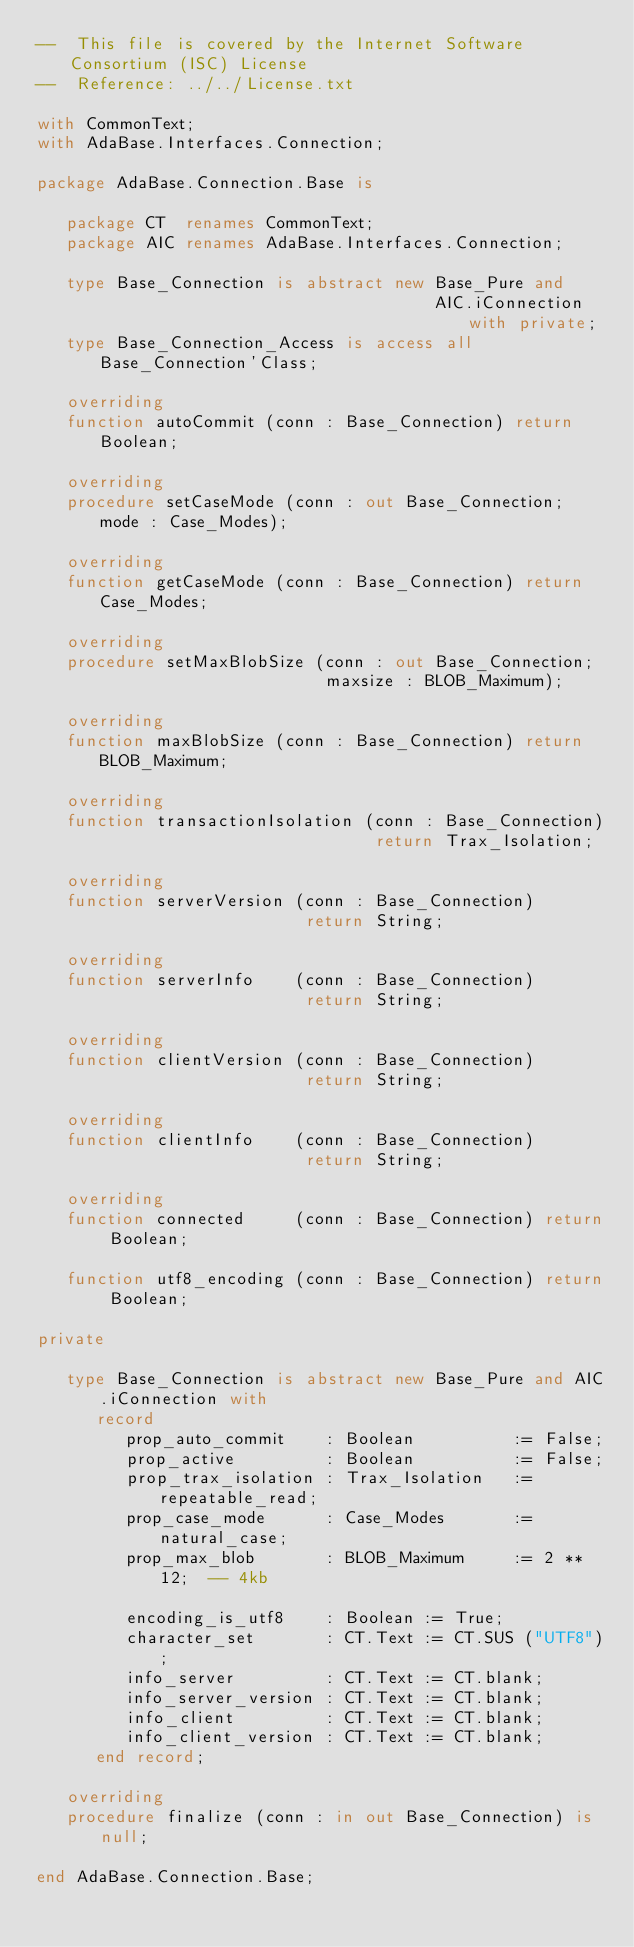<code> <loc_0><loc_0><loc_500><loc_500><_Ada_>--  This file is covered by the Internet Software Consortium (ISC) License
--  Reference: ../../License.txt

with CommonText;
with AdaBase.Interfaces.Connection;

package AdaBase.Connection.Base is

   package CT  renames CommonText;
   package AIC renames AdaBase.Interfaces.Connection;

   type Base_Connection is abstract new Base_Pure and
                                        AIC.iConnection with private;
   type Base_Connection_Access is access all Base_Connection'Class;

   overriding
   function autoCommit (conn : Base_Connection) return Boolean;

   overriding
   procedure setCaseMode (conn : out Base_Connection; mode : Case_Modes);

   overriding
   function getCaseMode (conn : Base_Connection) return Case_Modes;

   overriding
   procedure setMaxBlobSize (conn : out Base_Connection;
                             maxsize : BLOB_Maximum);

   overriding
   function maxBlobSize (conn : Base_Connection) return BLOB_Maximum;

   overriding
   function transactionIsolation (conn : Base_Connection)
                                  return Trax_Isolation;

   overriding
   function serverVersion (conn : Base_Connection)
                           return String;

   overriding
   function serverInfo    (conn : Base_Connection)
                           return String;

   overriding
   function clientVersion (conn : Base_Connection)
                           return String;

   overriding
   function clientInfo    (conn : Base_Connection)
                           return String;

   overriding
   function connected     (conn : Base_Connection) return Boolean;

   function utf8_encoding (conn : Base_Connection) return Boolean;

private

   type Base_Connection is abstract new Base_Pure and AIC.iConnection with
      record
         prop_auto_commit    : Boolean          := False;
         prop_active         : Boolean          := False;
         prop_trax_isolation : Trax_Isolation   := repeatable_read;
         prop_case_mode      : Case_Modes       := natural_case;
         prop_max_blob       : BLOB_Maximum     := 2 ** 12;  -- 4kb

         encoding_is_utf8    : Boolean := True;
         character_set       : CT.Text := CT.SUS ("UTF8");
         info_server         : CT.Text := CT.blank;
         info_server_version : CT.Text := CT.blank;
         info_client         : CT.Text := CT.blank;
         info_client_version : CT.Text := CT.blank;
      end record;

   overriding
   procedure finalize (conn : in out Base_Connection) is null;

end AdaBase.Connection.Base;
</code> 